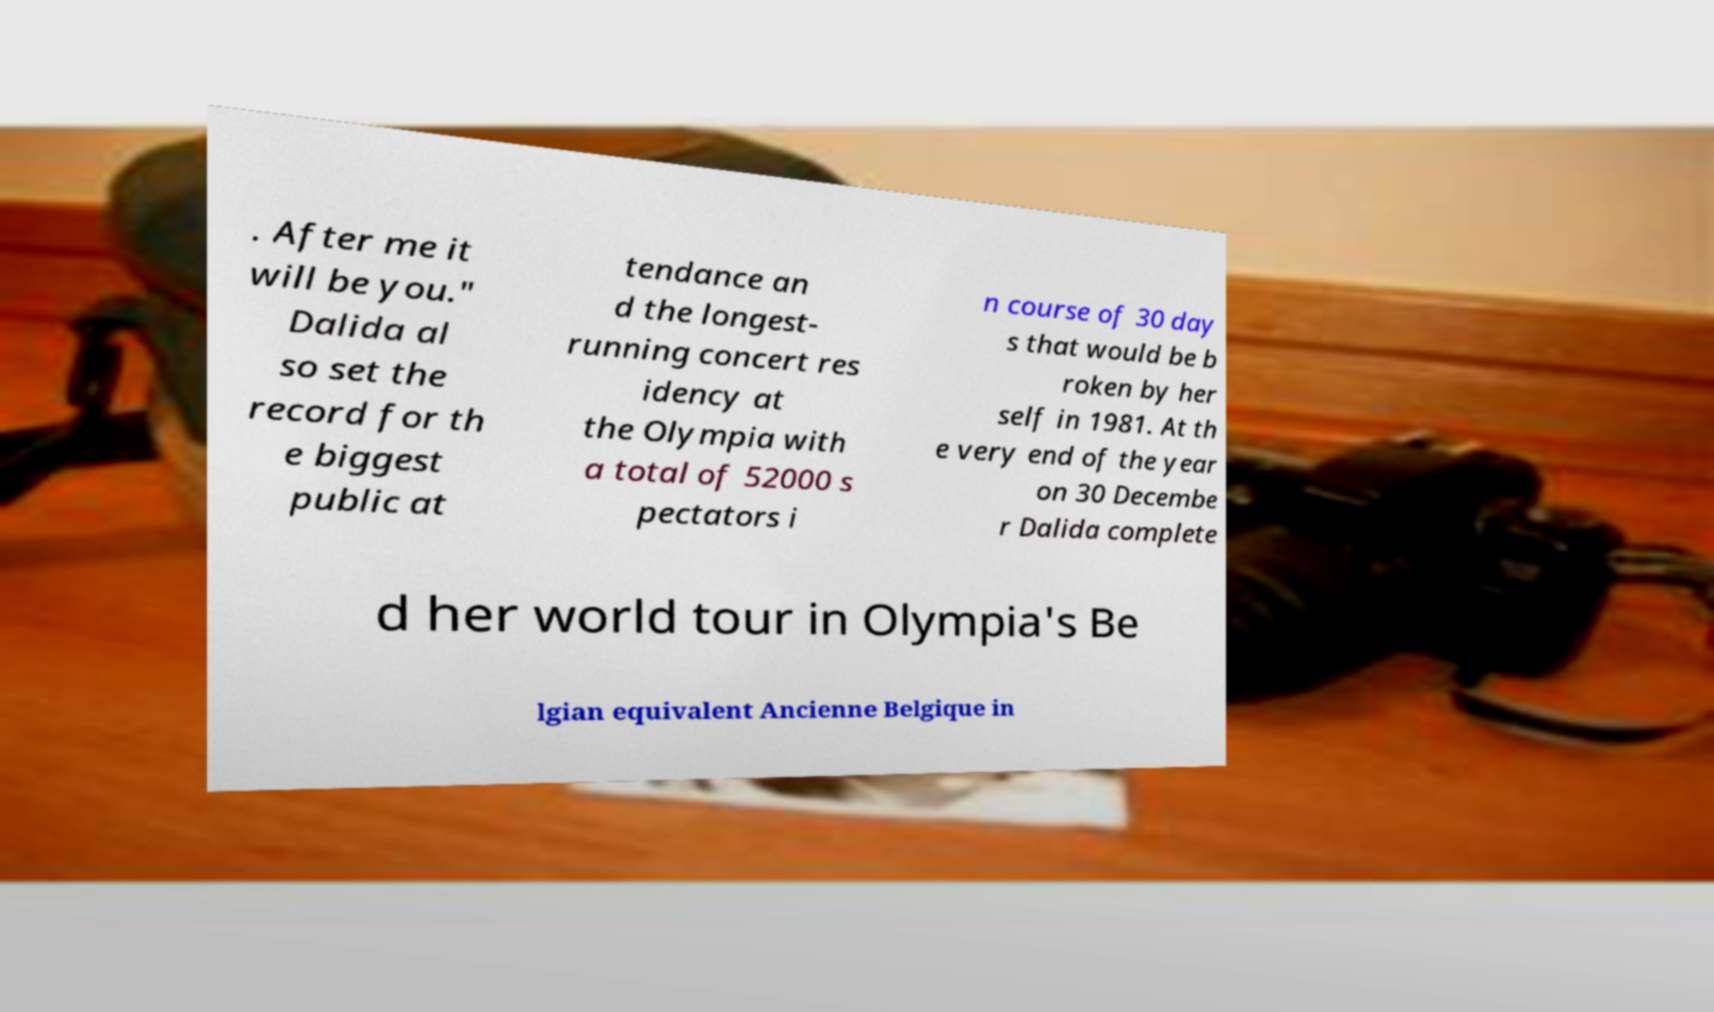Please identify and transcribe the text found in this image. . After me it will be you." Dalida al so set the record for th e biggest public at tendance an d the longest- running concert res idency at the Olympia with a total of 52000 s pectators i n course of 30 day s that would be b roken by her self in 1981. At th e very end of the year on 30 Decembe r Dalida complete d her world tour in Olympia's Be lgian equivalent Ancienne Belgique in 